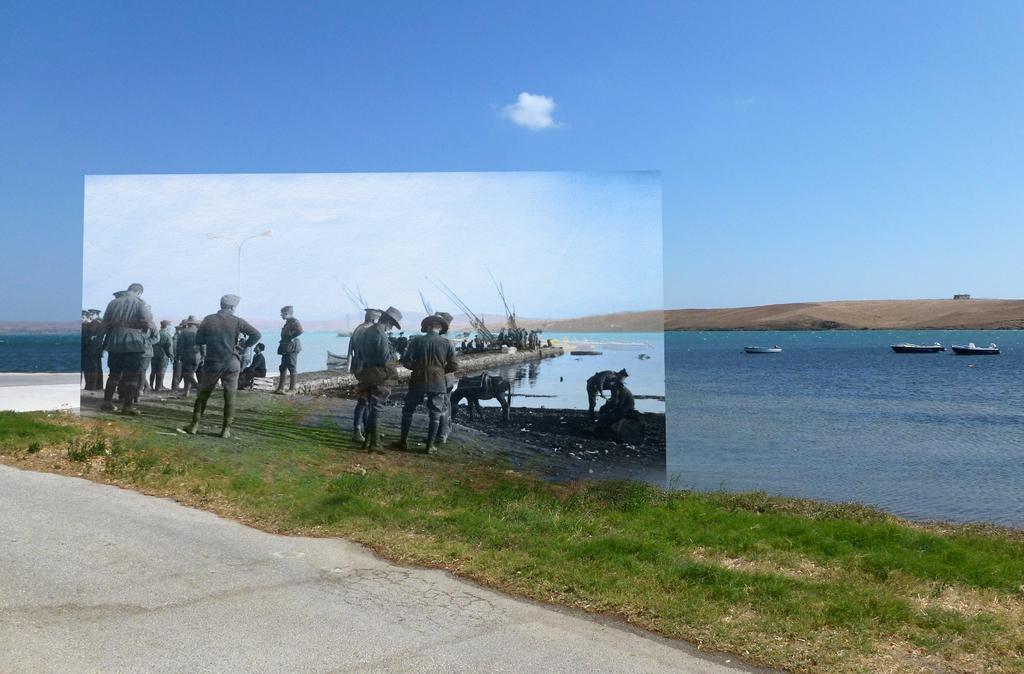Could you give a brief overview of what you see in this image? This picture consists of the sky at the top and the lake and there are group of persons standing in front of the lake and I can see grass beside the persons on the lake I can see boats. 